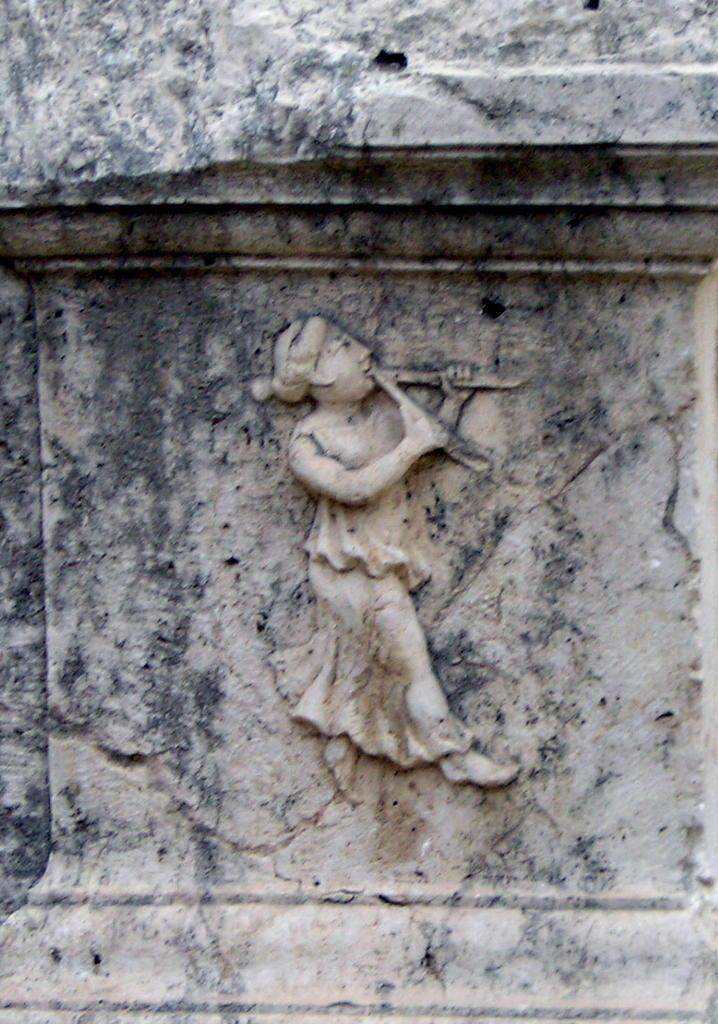What is on the wall in the image? There is a sculpture on the wall in the image. What type of liquid is being poured by the monkey in the image? There is no monkey present in the image, and therefore no liquid being poured. 